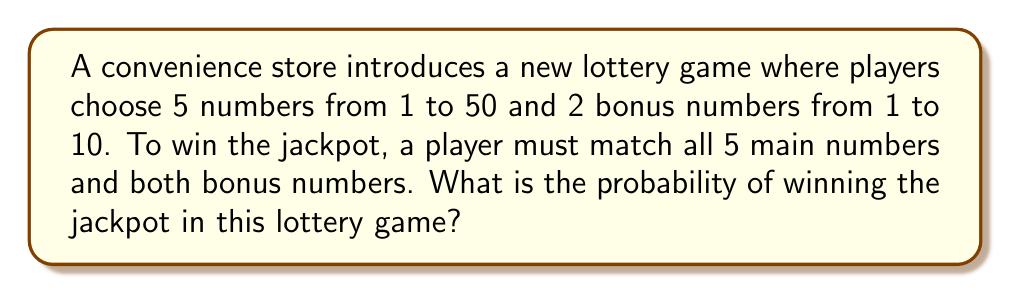Teach me how to tackle this problem. To calculate the probability of winning the jackpot, we need to determine the total number of possible combinations and compare it to the single winning combination.

Step 1: Calculate the number of ways to choose 5 main numbers from 50.
This is a combination problem, denoted as $\binom{50}{5}$.
$$\binom{50}{5} = \frac{50!}{5!(50-5)!} = \frac{50!}{5!45!} = 2,118,760$$

Step 2: Calculate the number of ways to choose 2 bonus numbers from 10.
This is another combination, $\binom{10}{2}$.
$$\binom{10}{2} = \frac{10!}{2!(10-2)!} = \frac{10!}{2!8!} = 45$$

Step 3: Calculate the total number of possible combinations.
Multiply the results from steps 1 and 2:
$$2,118,760 \times 45 = 95,344,200$$

Step 4: Calculate the probability of winning.
The probability is 1 (the single winning combination) divided by the total number of possible combinations:

$$P(\text{winning}) = \frac{1}{95,344,200}$$

This can be simplified to:
$$P(\text{winning}) = \frac{1}{95,344,200} \approx 1.049 \times 10^{-8}$$
Answer: $\frac{1}{95,344,200}$ 